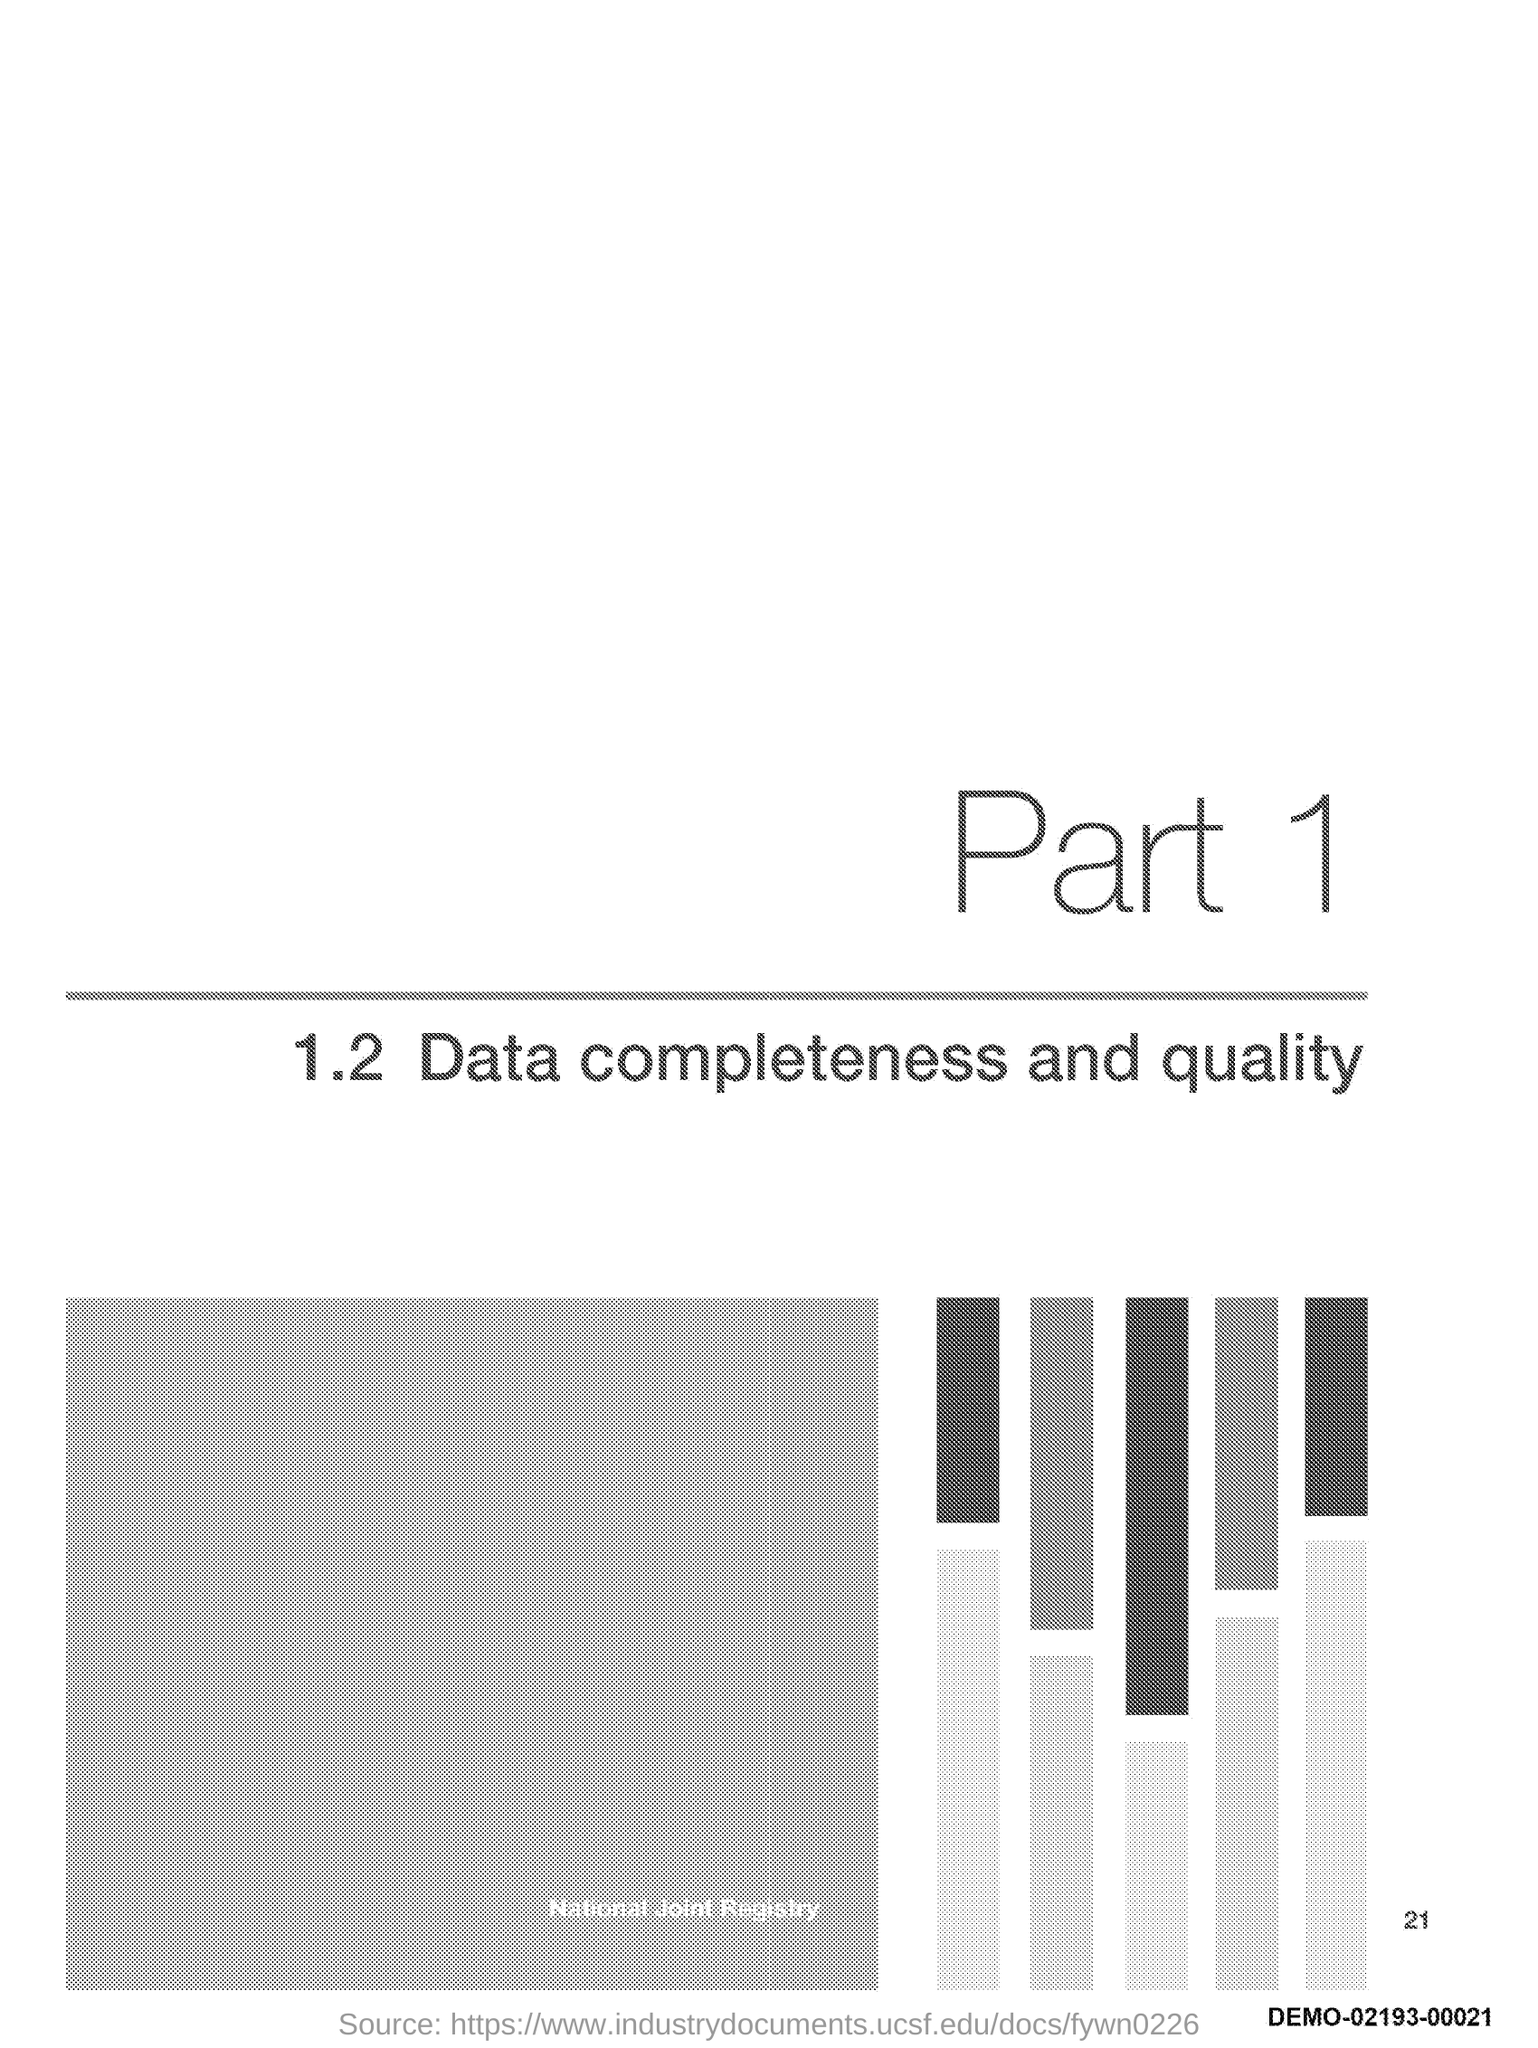Which Part is mentioned in the document?
Your answer should be very brief. Part 1. 